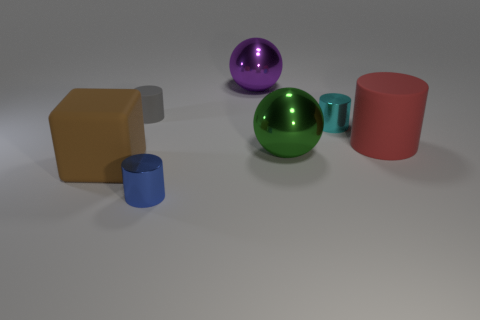Add 2 tiny metallic cubes. How many objects exist? 9 Subtract all purple cylinders. Subtract all red blocks. How many cylinders are left? 4 Subtract all cubes. How many objects are left? 6 Add 5 large red rubber objects. How many large red rubber objects are left? 6 Add 4 big purple metallic objects. How many big purple metallic objects exist? 5 Subtract 0 yellow blocks. How many objects are left? 7 Subtract all big purple metallic balls. Subtract all small blue objects. How many objects are left? 5 